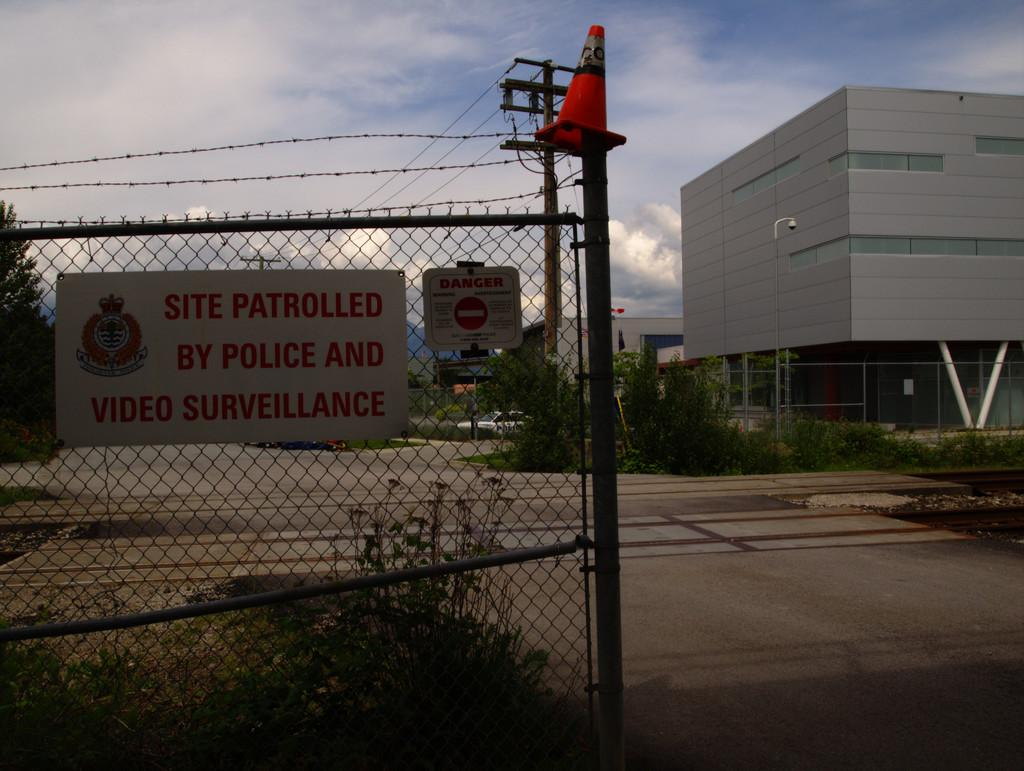What type of material is present in the image? There is a mesh in the image. What is attached to the mesh? There is a poster with text on it attached to the mesh. What type of structures can be seen in the image? There are buildings in the image. What type of vegetation is present in the image? There are plants in the image. What type of transportation infrastructure is present in the image? There is a road in the image. What type of utility infrastructure is present in the image? There are electric poles and electric wires in the image. What part of the natural environment is visible in the image? The sky is visible in the image. How many rabbits can be seen playing with a jellyfish in the image? There are no rabbits or jellyfish present in the image. What type of drawer is visible in the image? There is no drawer present in the image. 